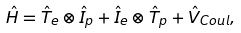<formula> <loc_0><loc_0><loc_500><loc_500>\hat { H } = \hat { T } _ { e } \otimes \hat { I } _ { p } + \hat { I } _ { e } \otimes \hat { T } _ { p } + \hat { V } _ { C o u l } ,</formula> 